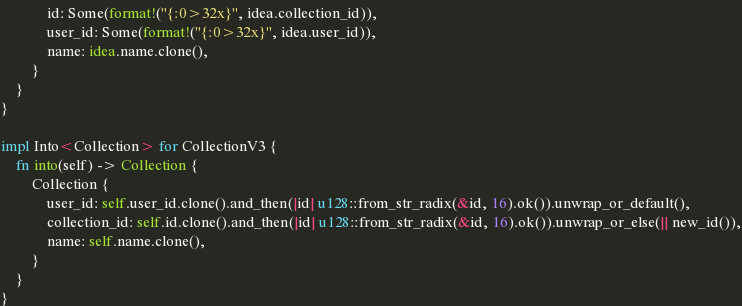<code> <loc_0><loc_0><loc_500><loc_500><_Rust_>            id: Some(format!("{:0>32x}", idea.collection_id)),
            user_id: Some(format!("{:0>32x}", idea.user_id)),
            name: idea.name.clone(),
        }
    }
}

impl Into<Collection> for CollectionV3 {
    fn into(self) -> Collection {
        Collection {
            user_id: self.user_id.clone().and_then(|id| u128::from_str_radix(&id, 16).ok()).unwrap_or_default(),
            collection_id: self.id.clone().and_then(|id| u128::from_str_radix(&id, 16).ok()).unwrap_or_else(|| new_id()),
            name: self.name.clone(),
        }
    }
}</code> 